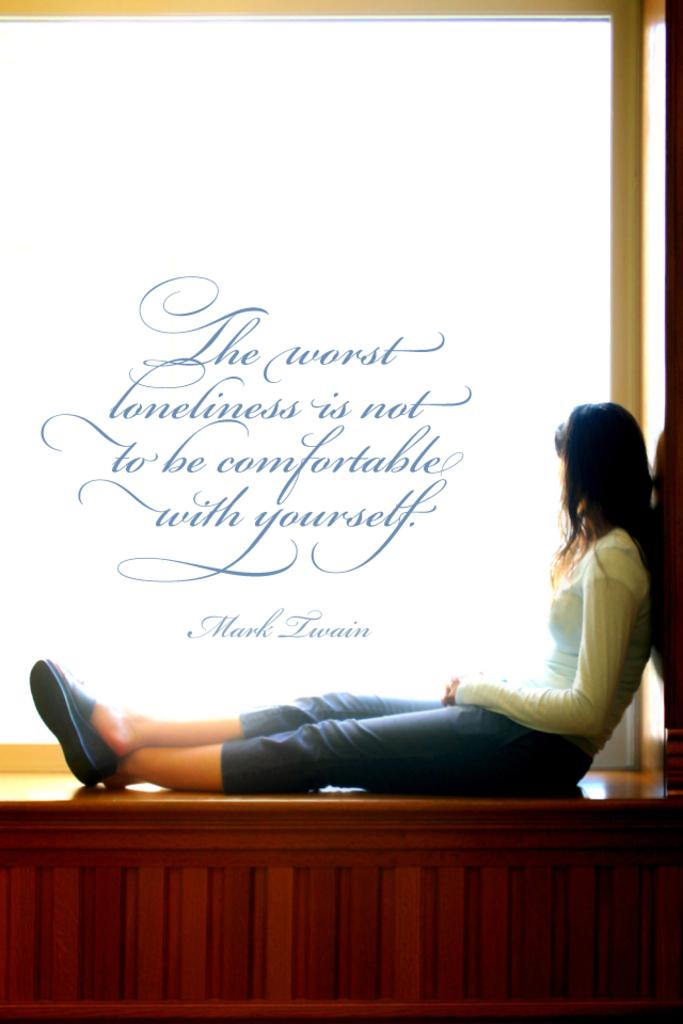What is the main subject of the image? The main subject of the image is a person sitting on a bench. Can you describe the person's position or activity in the image? The person is sitting on the bench. Is there any text visible in the image? Yes, there is some text written on the image. How many fish can be seen swimming in the hole in the image? There are no fish or holes present in the image; it features a person sitting on a bench with some text written on it. 